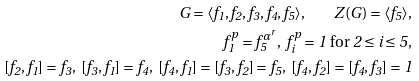Convert formula to latex. <formula><loc_0><loc_0><loc_500><loc_500>G = \langle f _ { 1 } , f _ { 2 } , f _ { 3 } , f _ { 4 } , f _ { 5 } \rangle , \quad Z ( G ) = \langle f _ { 5 } \rangle , \\ f _ { 1 } ^ { p } = f _ { 5 } ^ { \alpha ^ { r } } , \ f _ { i } ^ { p } = 1 \text { for } 2 \leq i \leq 5 , \\ [ f _ { 2 } , f _ { 1 } ] = f _ { 3 } , \ [ f _ { 3 } , f _ { 1 } ] = f _ { 4 } , \ [ f _ { 4 } , f _ { 1 } ] = [ f _ { 3 } , f _ { 2 } ] = f _ { 5 } , \ [ f _ { 4 } , f _ { 2 } ] = [ f _ { 4 } , f _ { 3 } ] = 1</formula> 